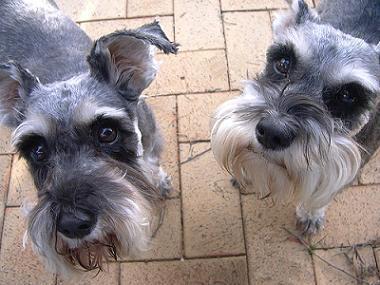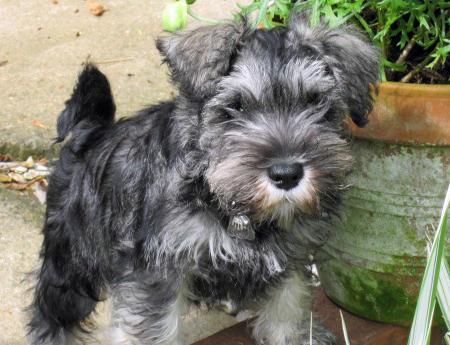The first image is the image on the left, the second image is the image on the right. Examine the images to the left and right. Is the description "An image shows two schnauzers of similar size and coloring posed side-by-side." accurate? Answer yes or no. Yes. The first image is the image on the left, the second image is the image on the right. Assess this claim about the two images: "At least one dog is showing its tongue.". Correct or not? Answer yes or no. No. 